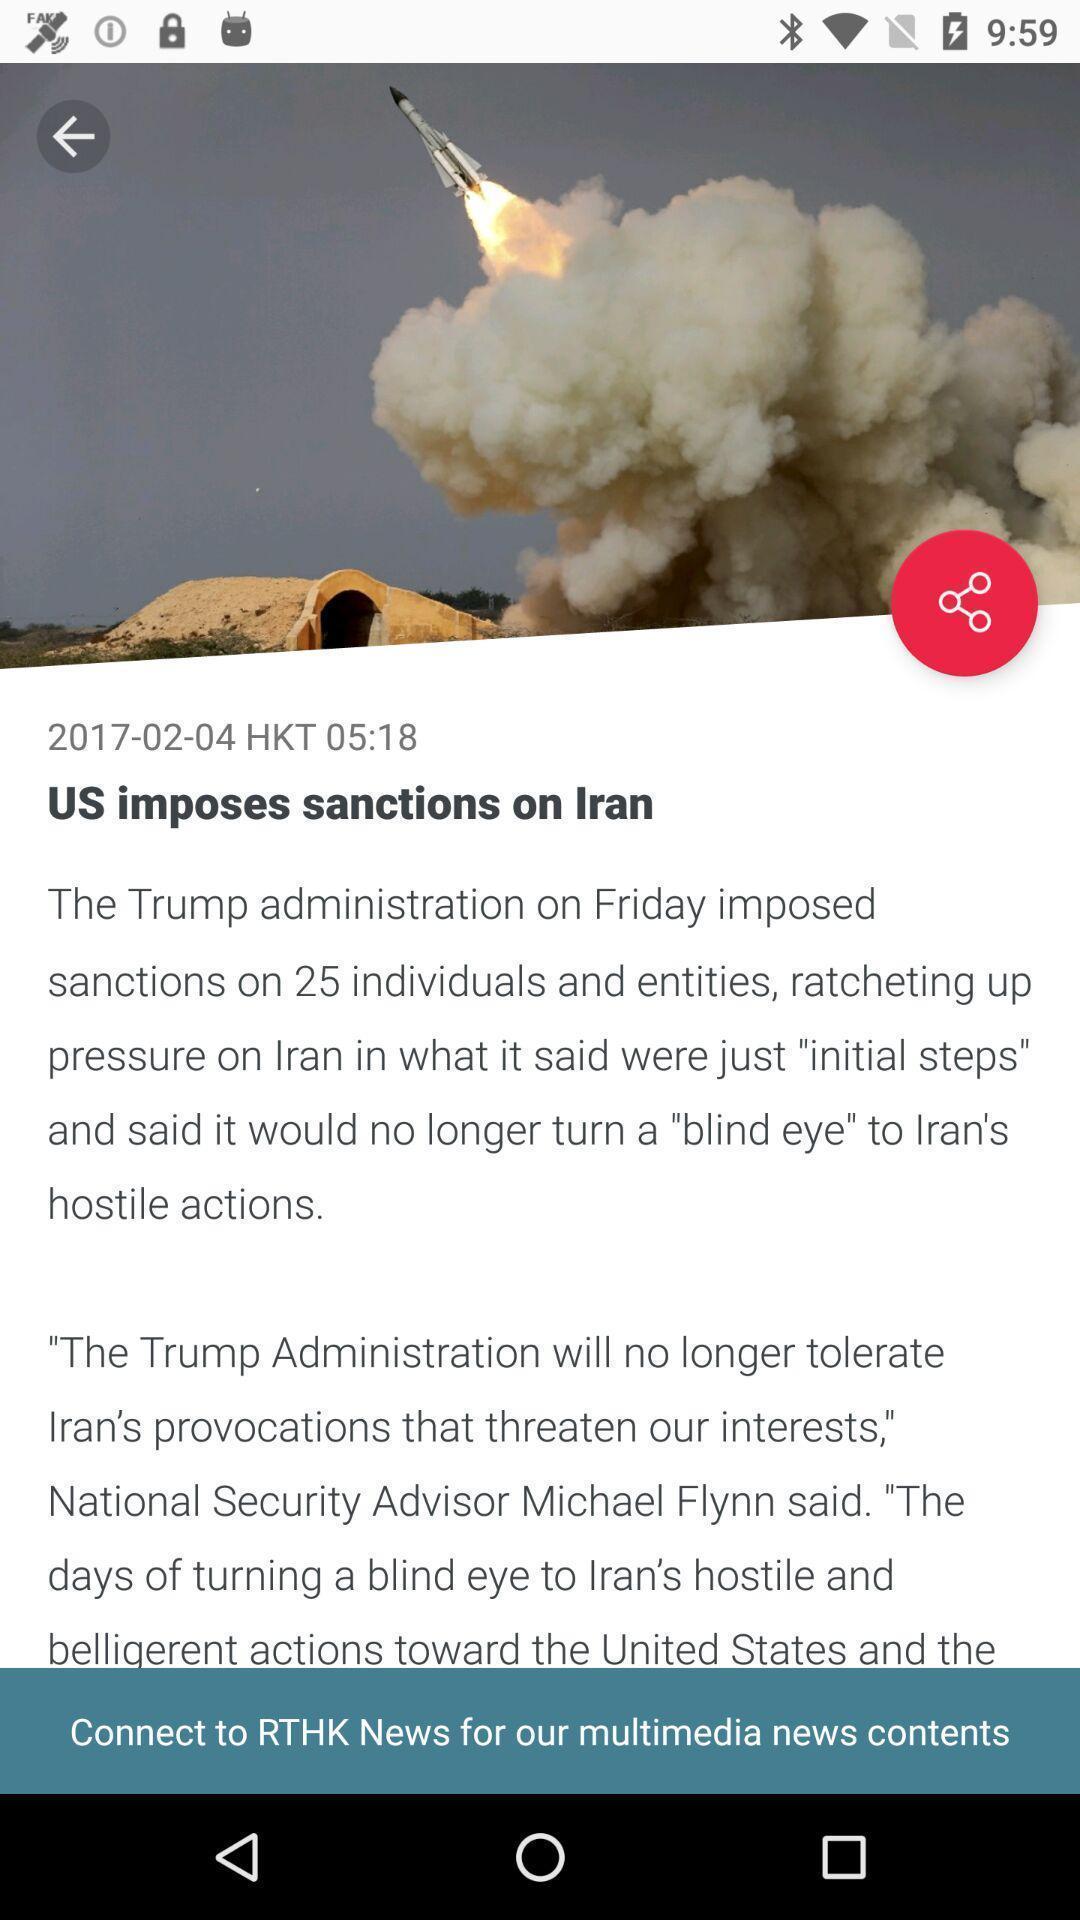Describe the content in this image. Page showing information of international matters. 